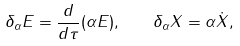<formula> <loc_0><loc_0><loc_500><loc_500>\delta _ { \alpha } E = \frac { d } { d \tau } ( \alpha E ) , \quad \delta _ { \alpha } X = \alpha \dot { X } ,</formula> 